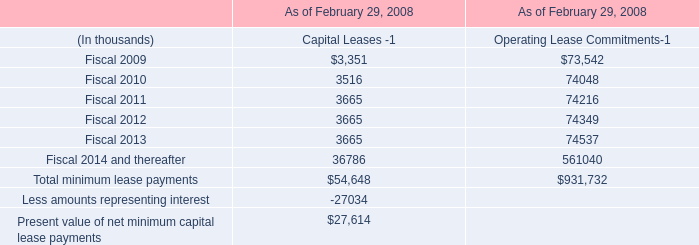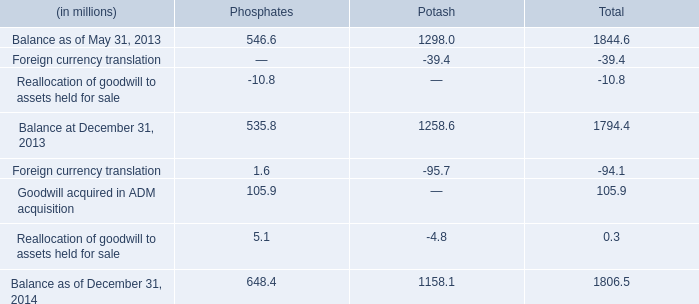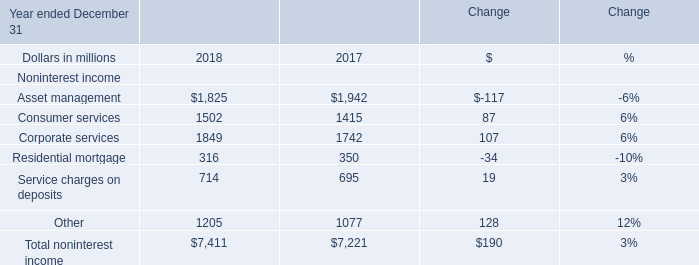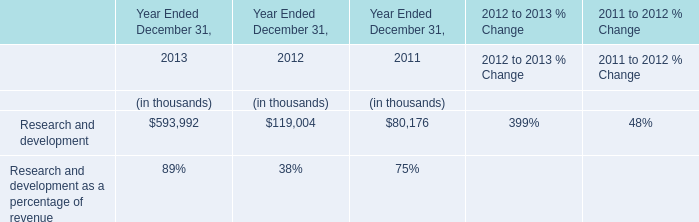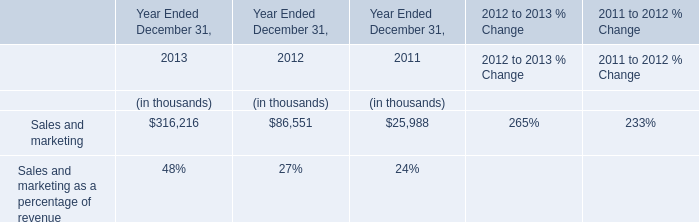Does Residential mortgage keeps increasing each year between 2017 and 2018? 
Answer: No. 